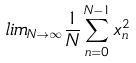<formula> <loc_0><loc_0><loc_500><loc_500>l i m _ { N \rightarrow \infty } \frac { 1 } { N } \sum _ { n = 0 } ^ { N - 1 } x _ { n } ^ { 2 }</formula> 